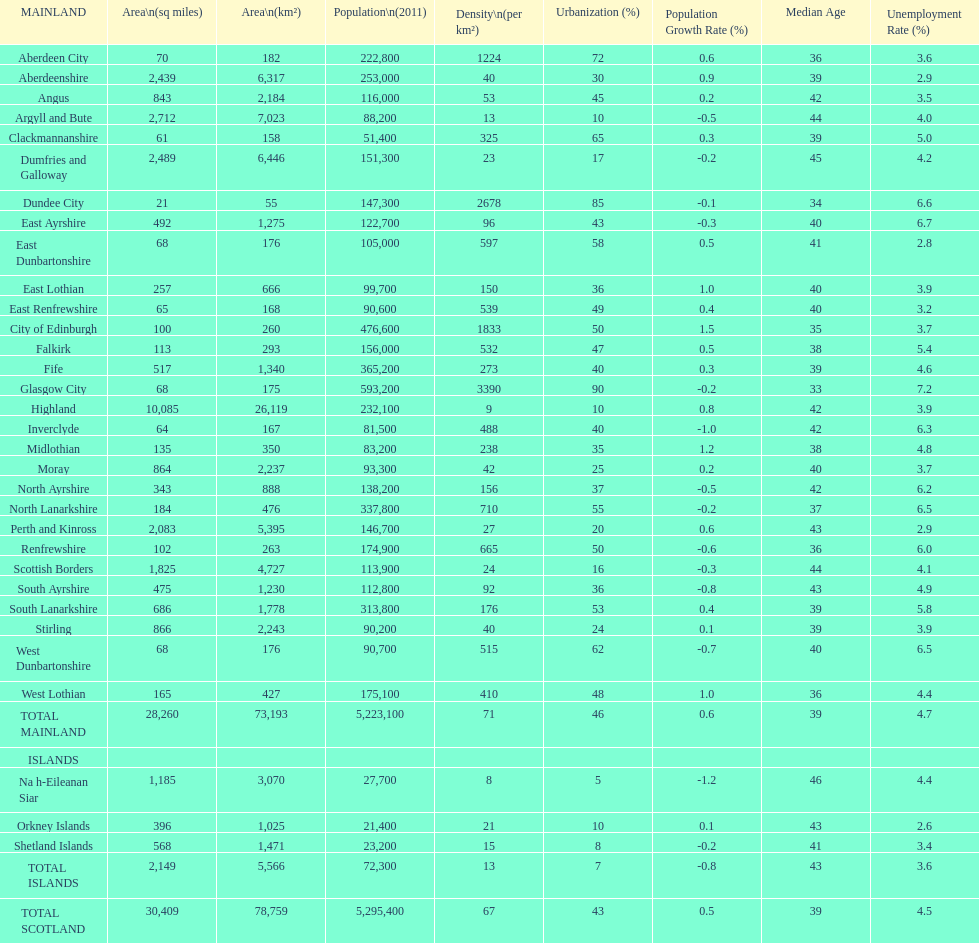What number of mainlands have populations under 100,000? 9. 